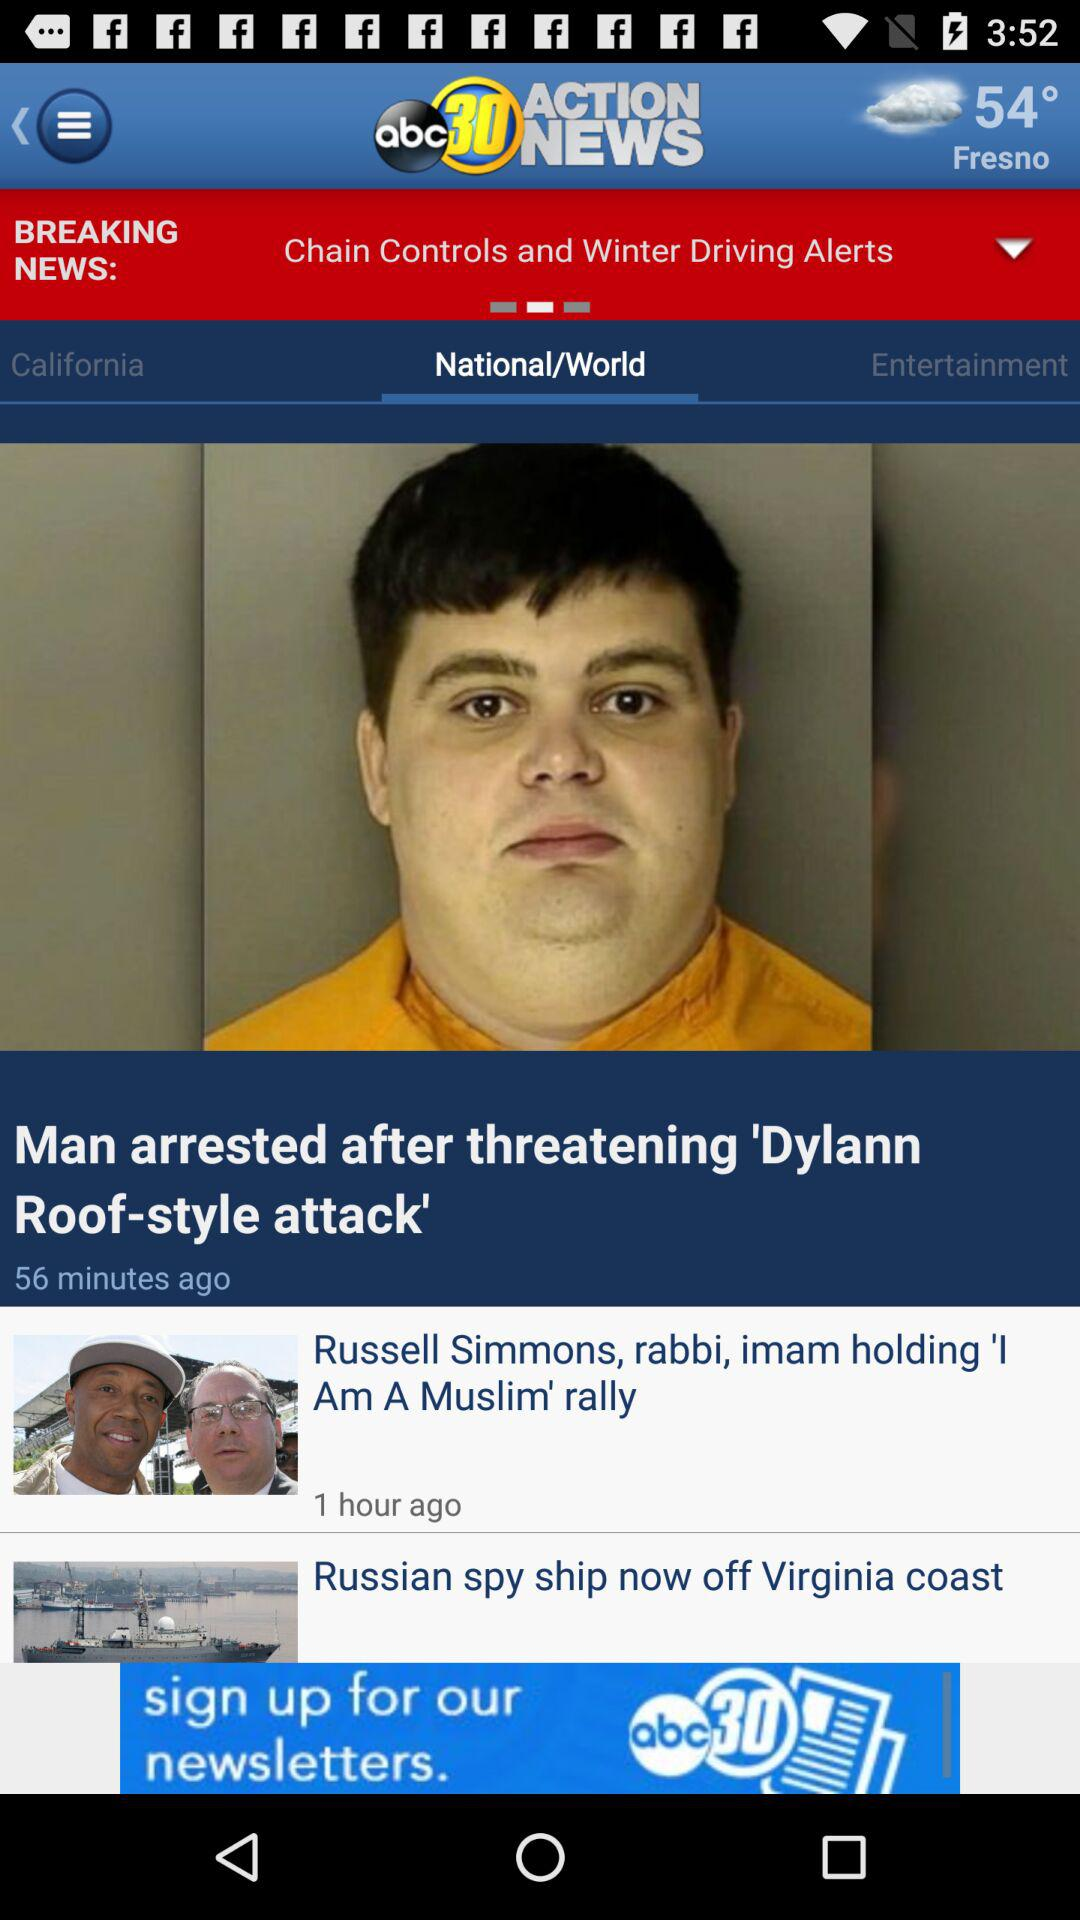Which tab is currently selected? The selected tab is "National/World". 